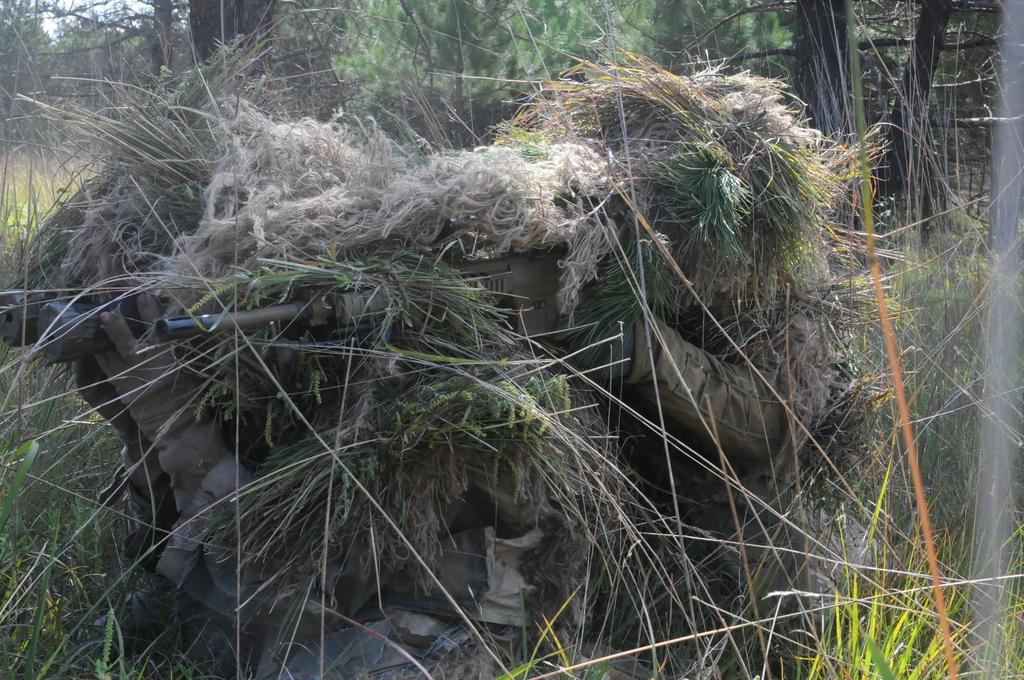How many persons are in the image? There are persons in the image. What are the persons holding in their hands? The persons are holding guns and binoculars. How are the persons camouflaged in the image? The persons are covered with grass. What can be seen in the background of the image? There are trees in the background of the image. What is the feeling of the grass in the image? The grass in the image does not have feelings; it is an inanimate object. 